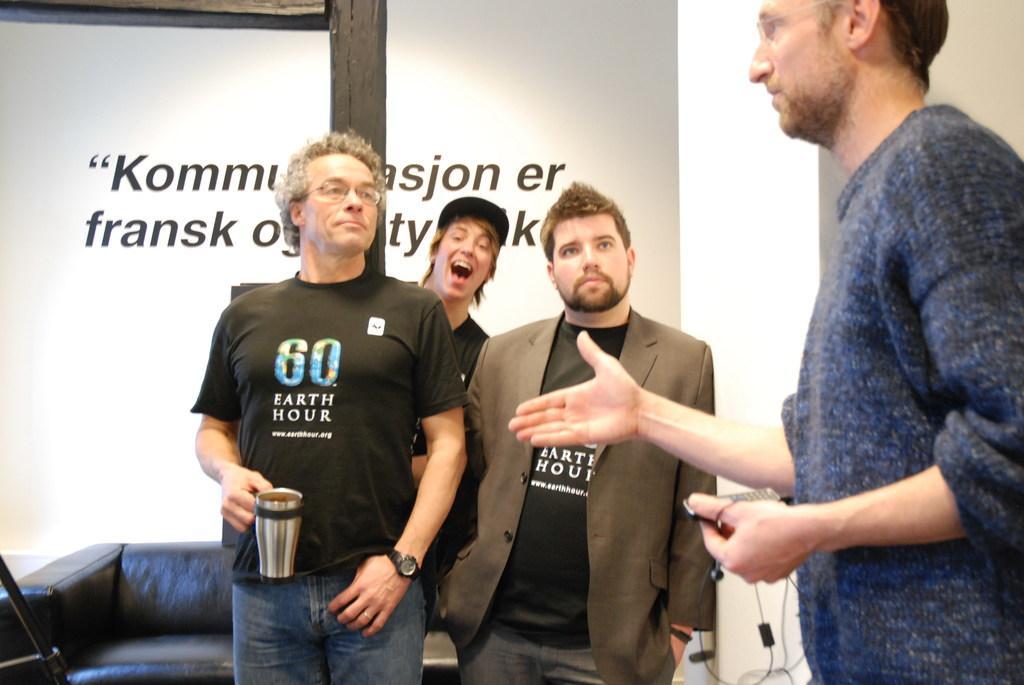Could you give a brief overview of what you see in this image? In this image we can see the persons standing on the floor. Of them one is holding a coffee mug in his hand and other is holding a i pod in his hand. Behind the persons we can see a sofa set and a wall with some text. 